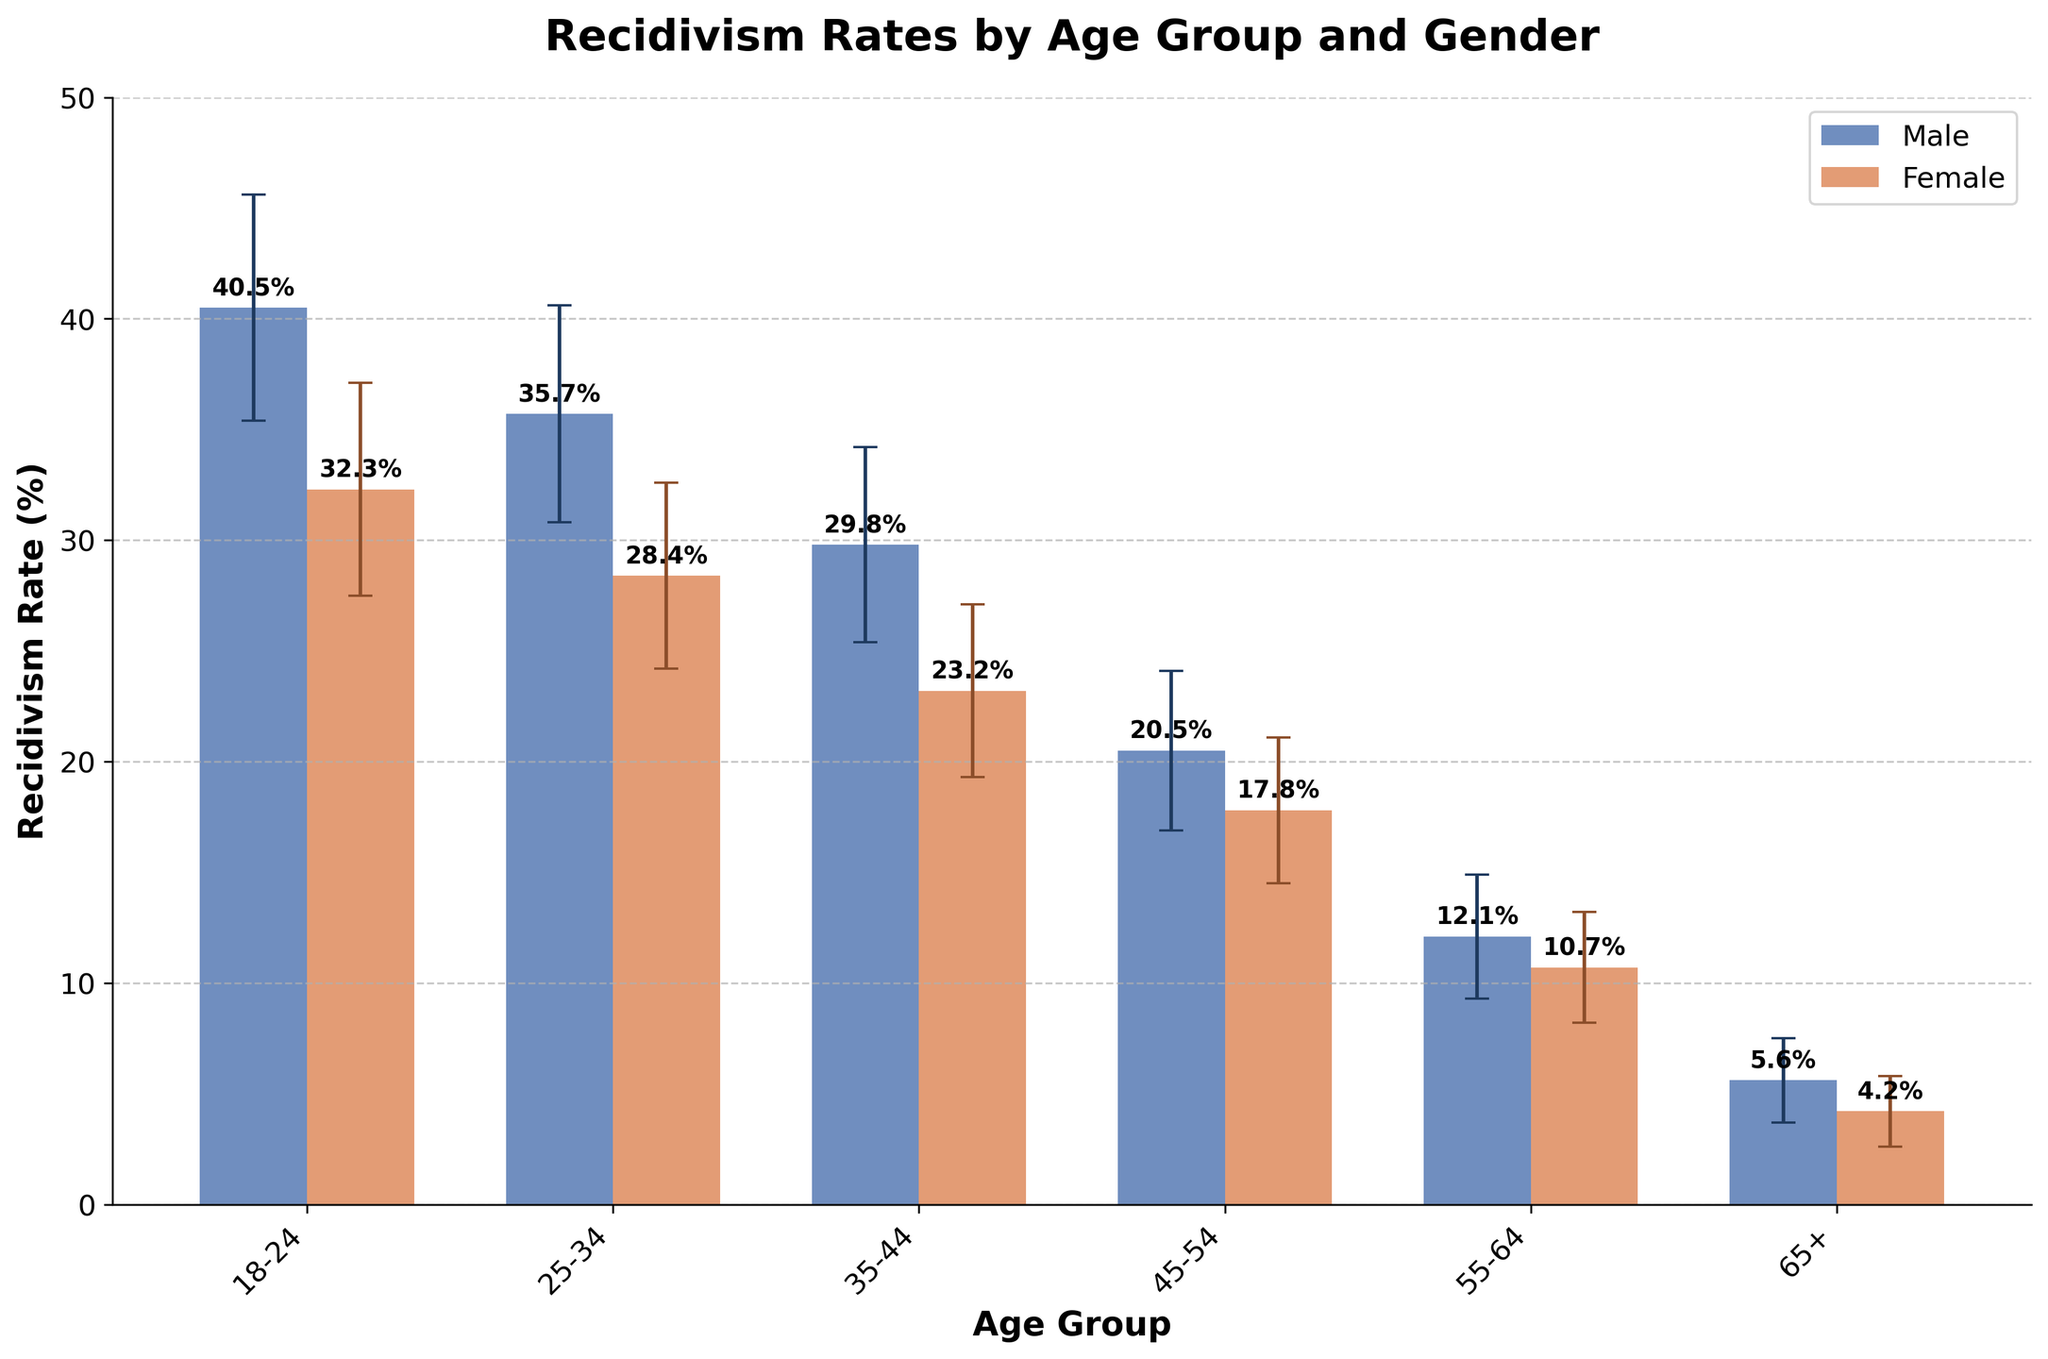What's the title of the figure? The title of a figure is typically displayed at the top. It provides a summary of what the chart is about.
Answer: Recidivism Rates by Age Group and Gender What does the X-axis represent? The X-axis labels are typically at the bottom of the chart. They provide information about the categories used.
Answer: Age Group Which gender has a higher recidivism rate in the 18-24 age group? The bars for the 18-24 age group can be compared to see which one is higher. The color corresponding to males is higher.
Answer: Male Which age group has the lowest recidivism rate overall? Look for the smallest bar across all age groups for both genders. The 65+ Female bar is the lowest.
Answer: 65+ What is the recidivism rate for females in the 25-34 age group? The height of the bar for females within the 25-34 age group gives the recidivism rate.
Answer: 28.4% By how much does the recidivism rate decrease from the 18-24 age group to the 25-34 age group for males? Subtract the recidivism rate of males in the 25-34 group from that in the 18-24 group.
Answer: 4.8% Which gender shows more variability in recidivism rates as indicated by the error bars? Compare the length of the error bars for each gender across age groups. Longer error bars indicate more variability.
Answer: Male How does the recidivism rate for males aged 45-54 compare to that for females in the same age group? Compare the heights of the bars for males and females in the 45-54 age group.
Answer: Males have a higher rate What is the difference in recidivism rates between males and females in the 35-44 age group? Subtract the recidivism rate of females in the 35-44 age group from that of males in the same group.
Answer: 6.6% For which age group is the discrepancy in recidivism rates between males and females the smallest? Evaluate the differences in rates between genders across all age groups and identify the smallest difference.
Answer: 55-64 